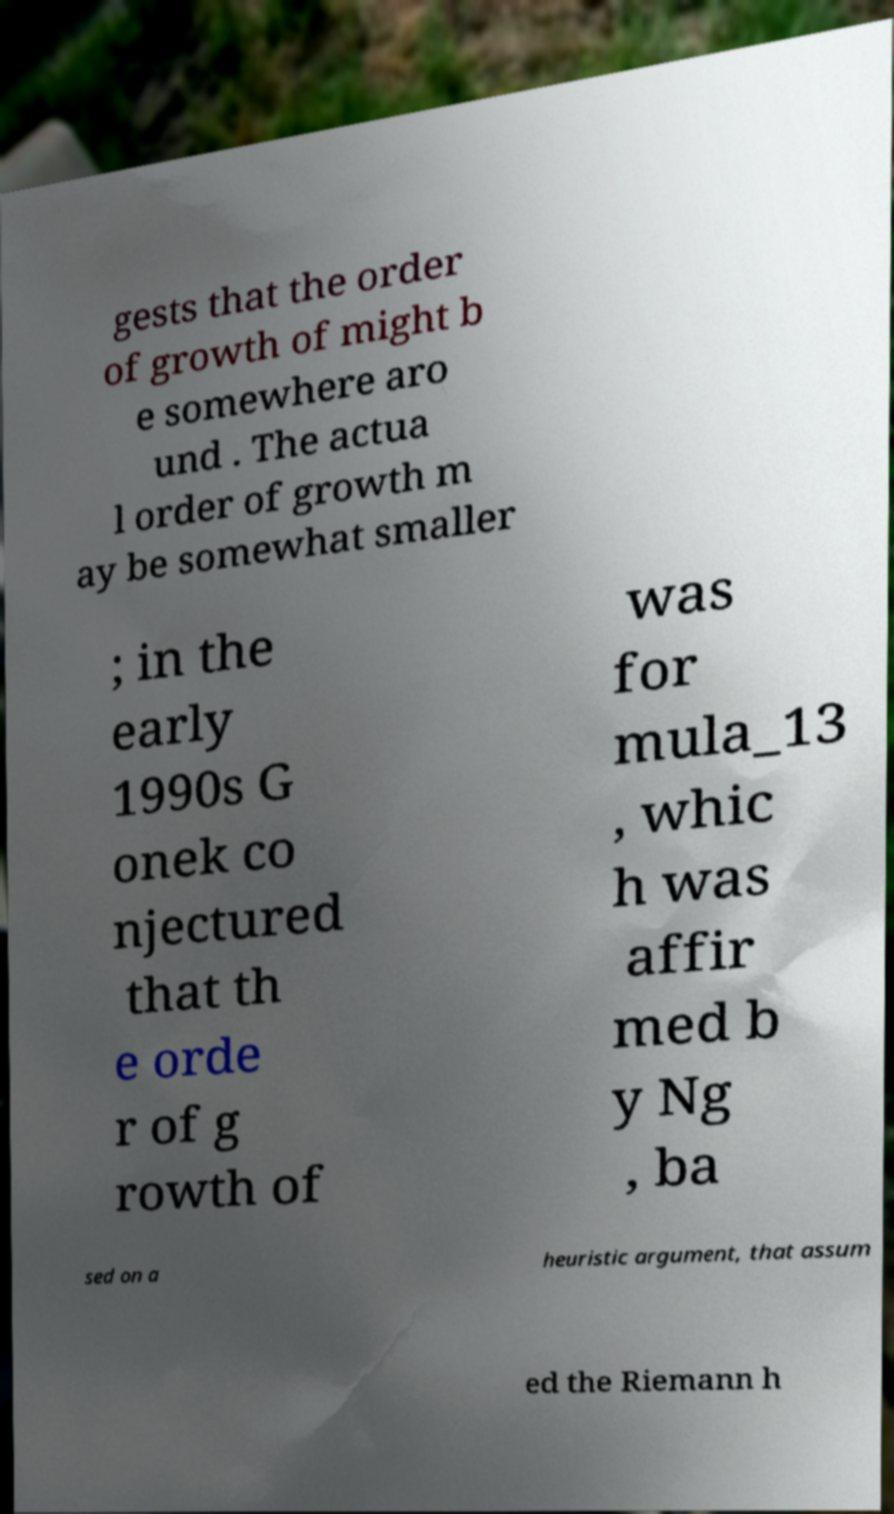What messages or text are displayed in this image? I need them in a readable, typed format. gests that the order of growth of might b e somewhere aro und . The actua l order of growth m ay be somewhat smaller ; in the early 1990s G onek co njectured that th e orde r of g rowth of was for mula_13 , whic h was affir med b y Ng , ba sed on a heuristic argument, that assum ed the Riemann h 